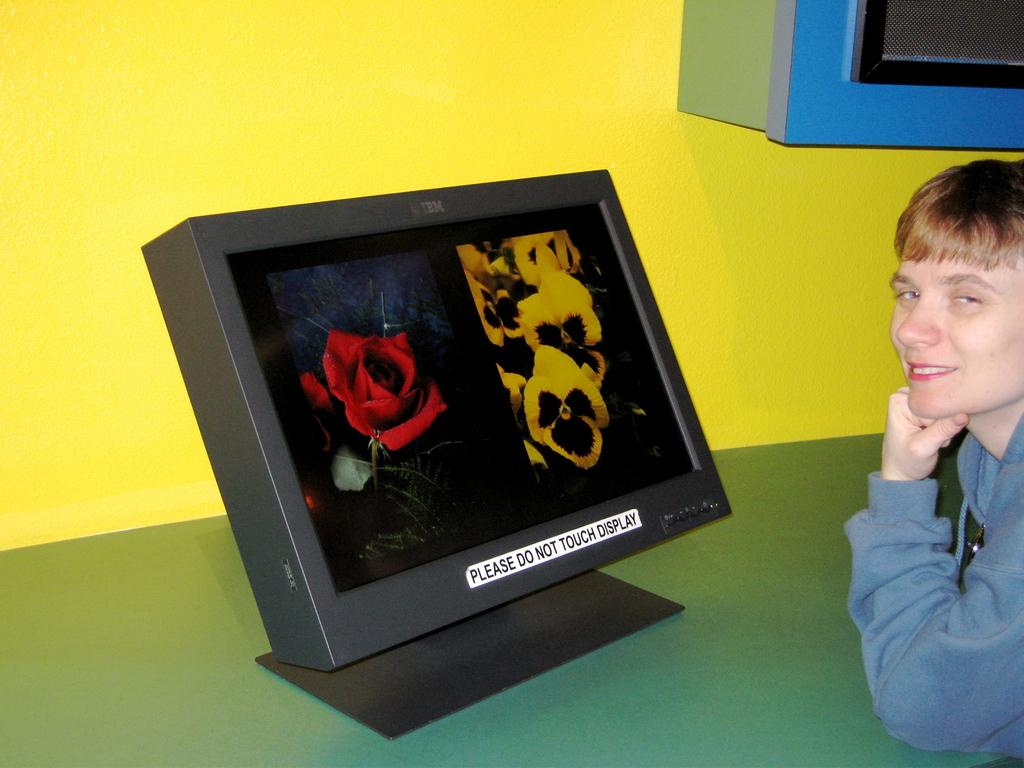What type of electronic device is in the image? There is a black monitor in the image. Where is the monitor located? The monitor is on a desk. Can you describe the person in the image? There is a man to the right of the monitor. What color is the wall behind the desk? There is a yellow wall in the background of the image. How many bananas are on the cushion in the image? There are no bananas or cushions present in the image. 